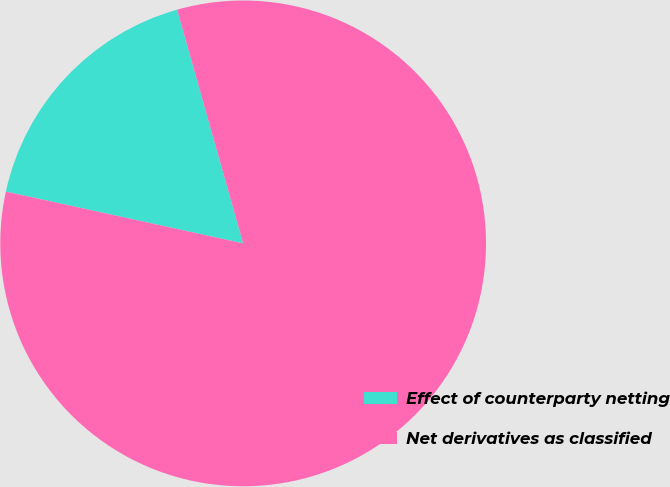Convert chart to OTSL. <chart><loc_0><loc_0><loc_500><loc_500><pie_chart><fcel>Effect of counterparty netting<fcel>Net derivatives as classified<nl><fcel>17.2%<fcel>82.8%<nl></chart> 